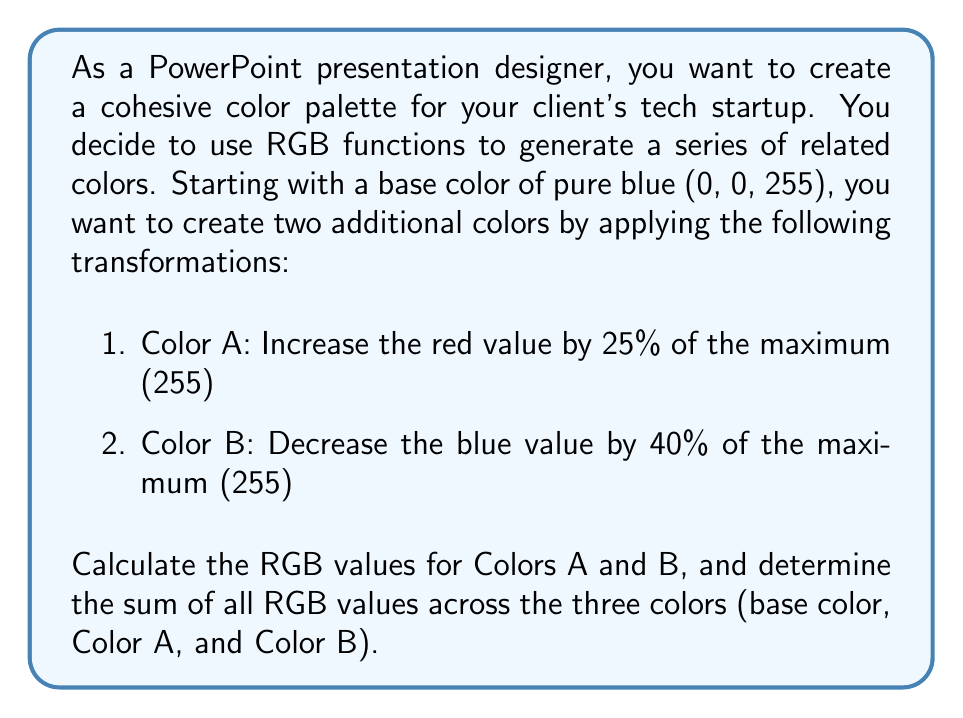Give your solution to this math problem. Let's approach this step-by-step:

1. Base color (pure blue): RGB(0, 0, 255)

2. Color A:
   - Red: Increase by 25% of 255
   $$ 0 + (0.25 \times 255) = 0 + 63.75 = 63.75 $$
   Round to the nearest integer: 64
   - Green: Remains 0
   - Blue: Remains 255
   
   Color A: RGB(64, 0, 255)

3. Color B:
   - Red: Remains 0
   - Green: Remains 0
   - Blue: Decrease by 40% of 255
   $$ 255 - (0.40 \times 255) = 255 - 102 = 153 $$
   
   Color B: RGB(0, 0, 153)

4. Sum of all RGB values:
   Base color: $0 + 0 + 255 = 255$
   Color A: $64 + 0 + 255 = 319$
   Color B: $0 + 0 + 153 = 153$
   
   Total sum: $255 + 319 + 153 = 727$
Answer: The RGB values for the three colors are:
Base color: RGB(0, 0, 255)
Color A: RGB(64, 0, 255)
Color B: RGB(0, 0, 153)

The sum of all RGB values across the three colors is 727. 